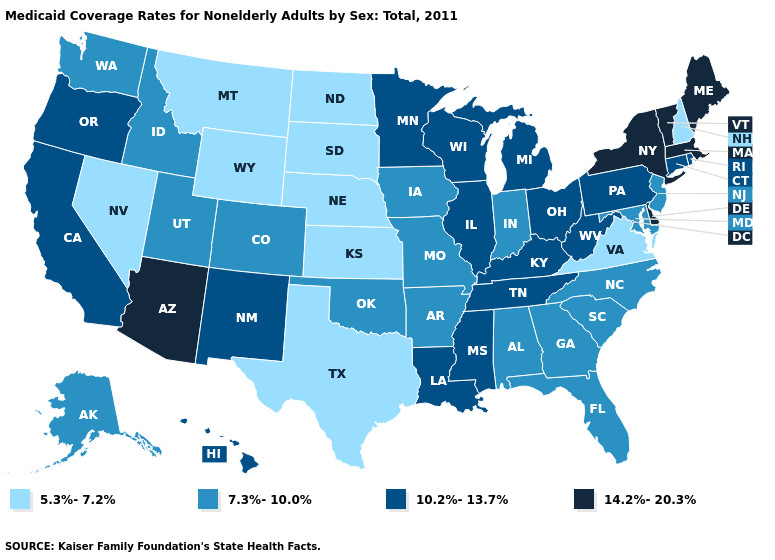Among the states that border Montana , which have the lowest value?
Write a very short answer. North Dakota, South Dakota, Wyoming. Does Delaware have the highest value in the USA?
Keep it brief. Yes. What is the highest value in states that border Minnesota?
Keep it brief. 10.2%-13.7%. What is the highest value in the USA?
Answer briefly. 14.2%-20.3%. Name the states that have a value in the range 14.2%-20.3%?
Give a very brief answer. Arizona, Delaware, Maine, Massachusetts, New York, Vermont. What is the value of Louisiana?
Write a very short answer. 10.2%-13.7%. Does New Jersey have the same value as Missouri?
Answer briefly. Yes. Does Nevada have the lowest value in the USA?
Be succinct. Yes. What is the highest value in the USA?
Quick response, please. 14.2%-20.3%. Name the states that have a value in the range 10.2%-13.7%?
Answer briefly. California, Connecticut, Hawaii, Illinois, Kentucky, Louisiana, Michigan, Minnesota, Mississippi, New Mexico, Ohio, Oregon, Pennsylvania, Rhode Island, Tennessee, West Virginia, Wisconsin. Which states hav the highest value in the West?
Be succinct. Arizona. Does Montana have the lowest value in the West?
Concise answer only. Yes. How many symbols are there in the legend?
Keep it brief. 4. Name the states that have a value in the range 14.2%-20.3%?
Keep it brief. Arizona, Delaware, Maine, Massachusetts, New York, Vermont. 